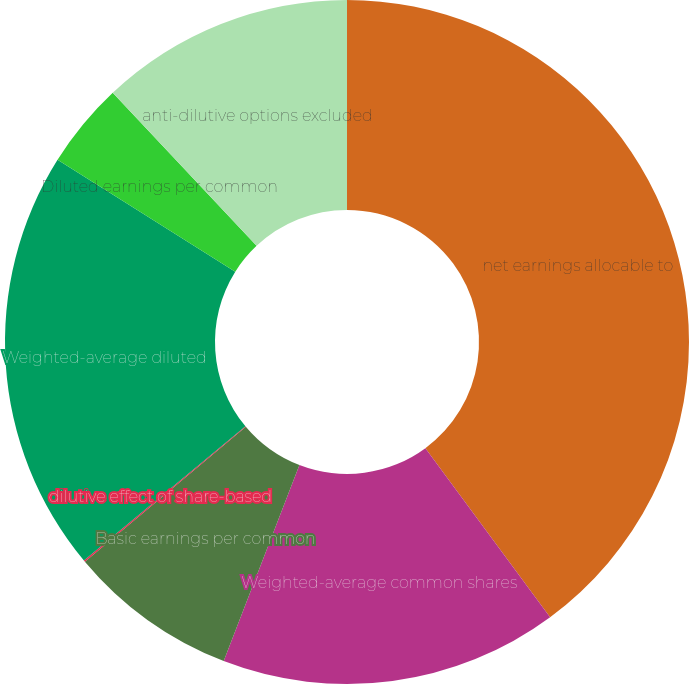Convert chart to OTSL. <chart><loc_0><loc_0><loc_500><loc_500><pie_chart><fcel>net earnings allocable to<fcel>Weighted-average common shares<fcel>Basic earnings per common<fcel>dilutive effect of share-based<fcel>Weighted-average diluted<fcel>Diluted earnings per common<fcel>anti-dilutive options excluded<nl><fcel>39.88%<fcel>15.99%<fcel>8.03%<fcel>0.07%<fcel>19.97%<fcel>4.05%<fcel>12.01%<nl></chart> 